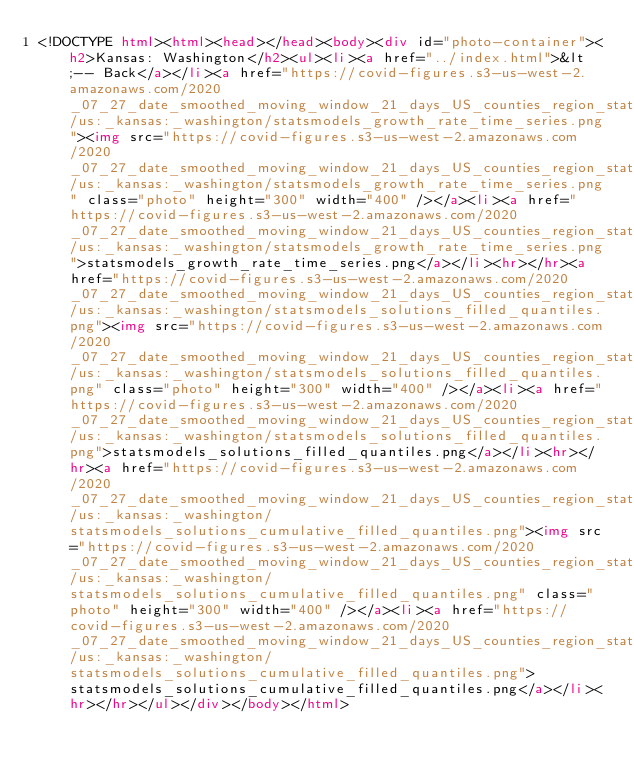Convert code to text. <code><loc_0><loc_0><loc_500><loc_500><_HTML_><!DOCTYPE html><html><head></head><body><div id="photo-container"><h2>Kansas: Washington</h2><ul><li><a href="../index.html">&lt;-- Back</a></li><a href="https://covid-figures.s3-us-west-2.amazonaws.com/2020_07_27_date_smoothed_moving_window_21_days_US_counties_region_statsmodels/us:_kansas:_washington/statsmodels_growth_rate_time_series.png"><img src="https://covid-figures.s3-us-west-2.amazonaws.com/2020_07_27_date_smoothed_moving_window_21_days_US_counties_region_statsmodels/us:_kansas:_washington/statsmodels_growth_rate_time_series.png" class="photo" height="300" width="400" /></a><li><a href="https://covid-figures.s3-us-west-2.amazonaws.com/2020_07_27_date_smoothed_moving_window_21_days_US_counties_region_statsmodels/us:_kansas:_washington/statsmodels_growth_rate_time_series.png">statsmodels_growth_rate_time_series.png</a></li><hr></hr><a href="https://covid-figures.s3-us-west-2.amazonaws.com/2020_07_27_date_smoothed_moving_window_21_days_US_counties_region_statsmodels/us:_kansas:_washington/statsmodels_solutions_filled_quantiles.png"><img src="https://covid-figures.s3-us-west-2.amazonaws.com/2020_07_27_date_smoothed_moving_window_21_days_US_counties_region_statsmodels/us:_kansas:_washington/statsmodels_solutions_filled_quantiles.png" class="photo" height="300" width="400" /></a><li><a href="https://covid-figures.s3-us-west-2.amazonaws.com/2020_07_27_date_smoothed_moving_window_21_days_US_counties_region_statsmodels/us:_kansas:_washington/statsmodels_solutions_filled_quantiles.png">statsmodels_solutions_filled_quantiles.png</a></li><hr></hr><a href="https://covid-figures.s3-us-west-2.amazonaws.com/2020_07_27_date_smoothed_moving_window_21_days_US_counties_region_statsmodels/us:_kansas:_washington/statsmodels_solutions_cumulative_filled_quantiles.png"><img src="https://covid-figures.s3-us-west-2.amazonaws.com/2020_07_27_date_smoothed_moving_window_21_days_US_counties_region_statsmodels/us:_kansas:_washington/statsmodels_solutions_cumulative_filled_quantiles.png" class="photo" height="300" width="400" /></a><li><a href="https://covid-figures.s3-us-west-2.amazonaws.com/2020_07_27_date_smoothed_moving_window_21_days_US_counties_region_statsmodels/us:_kansas:_washington/statsmodels_solutions_cumulative_filled_quantiles.png">statsmodels_solutions_cumulative_filled_quantiles.png</a></li><hr></hr></ul></div></body></html></code> 